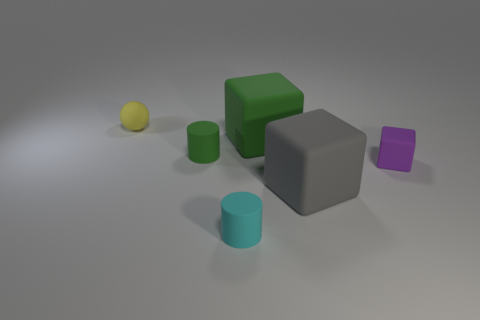What can you infer about the lighting in the scene? The lighting in the image seems to come from above, casting soft shadows directly beneath the objects. The shadows are slightly elongated, suggesting that the light source is not directly overhead but at a slight angle. The softness of the shadows indicates that the light source may be diffused. Does the lighting create any particular mood or atmosphere? The lighting creates a calm and neutral atmosphere. There's no high contrast or dramatic shadows that would suggest a dynamic or tense mood. Instead, it's quite even and soft, which often conveys a serene and undisturbed setting. 